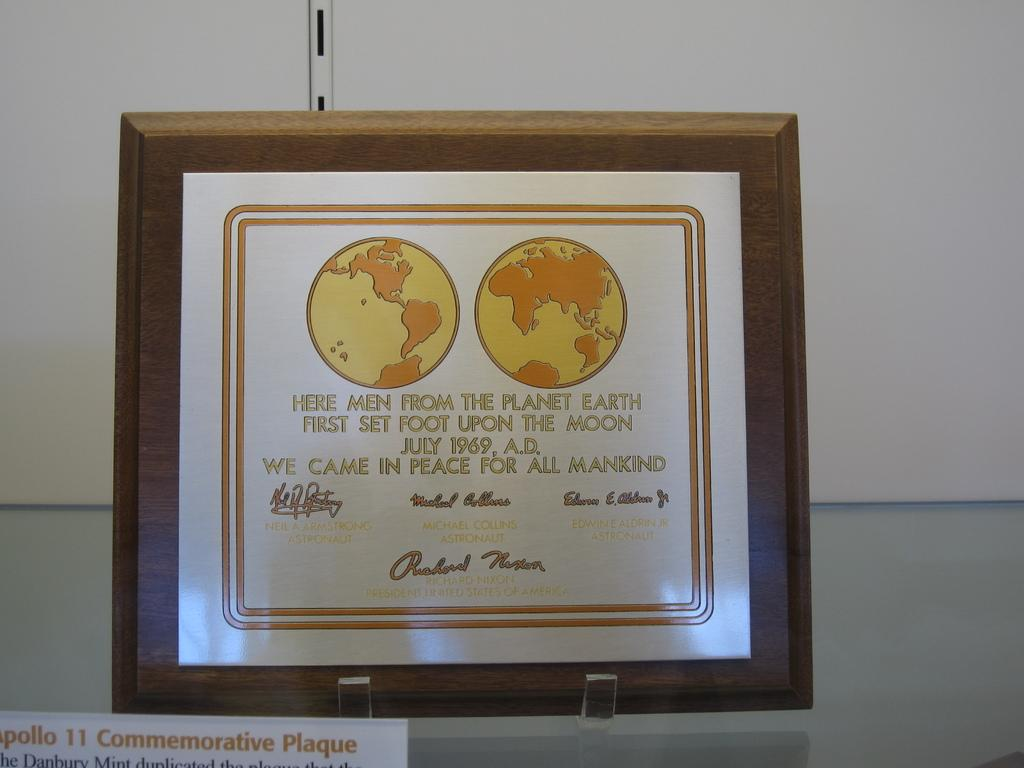<image>
Relay a brief, clear account of the picture shown. a plaque from the Apollo 11 reads Here Men From the Planet Earth 